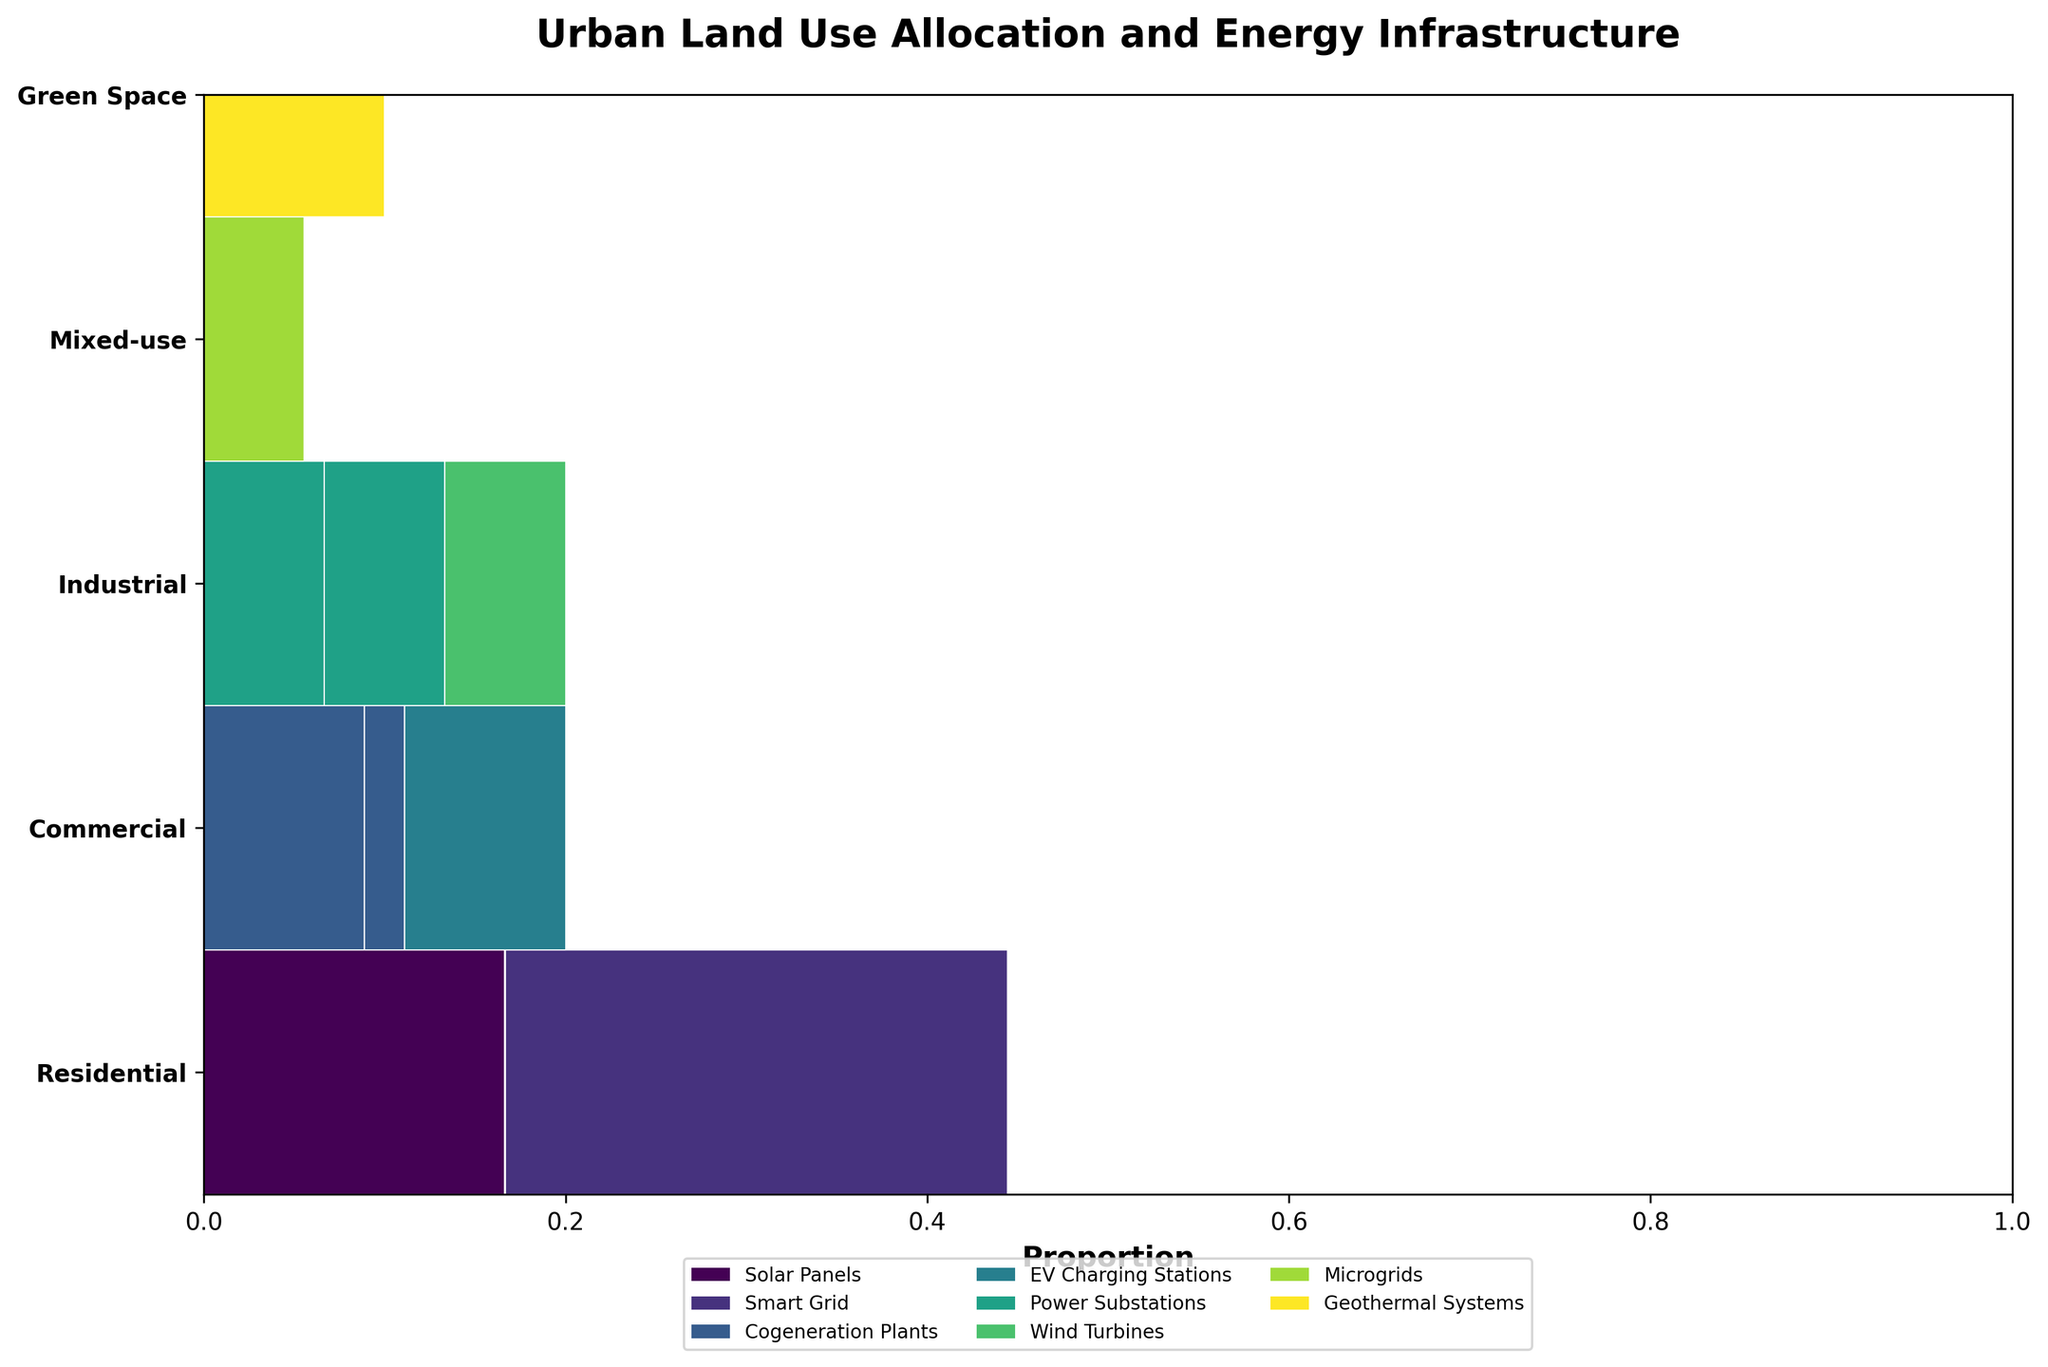What is the title of the plot? The title is usually displayed at the top of the plot in a larger or bold font to describe the contents of the figure. In this case, it is mentioned in the code.
Answer: Urban Land Use Allocation and Energy Infrastructure Which zone is associated with warehouses? From the plot, you can see that the "Industrial" zone contains the land use type "Warehouses."
Answer: Industrial What type of energy infrastructure has the largest proportion in the residential zone? By examining the colored proportions in the residential zone section, you can compare the sizes of areas corresponding to different energy infrastructures.
Answer: Smart Grid Which zone has the smallest allocation for EV Charging Stations? Look at the parts of the plot corresponding to EV Charging Stations across all zones. Identify which zone's section has the smallest area allocated to it.
Answer: Commercial Compare the areas of manufacturing plants with power substations and warehouses with wind turbines in the industrial zone. Which is larger? In the industrial zone, compare the areas (rectangles) representing "Manufacturing Plants with Power Substations" and "Warehouses with Wind Turbines." The size of the rectangles will tell you which combination is larger.
Answer: Manufacturing Plants with Power Substations In the mixed-use zone, what type of energy infrastructure is used? Locate the mixed-use zone section of the plot and identify the corresponding energy infrastructure from the legend and color.
Answer: Microgrids What is the total area allocation for green spaces with geothermal systems? Locate the green spaces section and identify the colored area corresponding to geothermal systems. Then sum up the corresponding plot areas.
Answer: 9 sq km How does the area allocation for urban core with microgrids compare to office buildings with cogeneration plants? Look at the areas for "Urban Core with Microgrids" and "Office Buildings with Cogeneration Plants" across their respective zones and compare the sizes.
Answer: Urban Core with Microgrids is smaller What land use type dominates the commercial zone? Examine the commercial zone sections to see which land use type (Office Buildings or Shopping Centers) has the larger proportion of the area.
Answer: Office Buildings Which zone has the highest total area allocation? Sum up the areas of all land use types within each zone by interpreting the sizes of rectangles, and identify the zone with the largest total.
Answer: Residential 